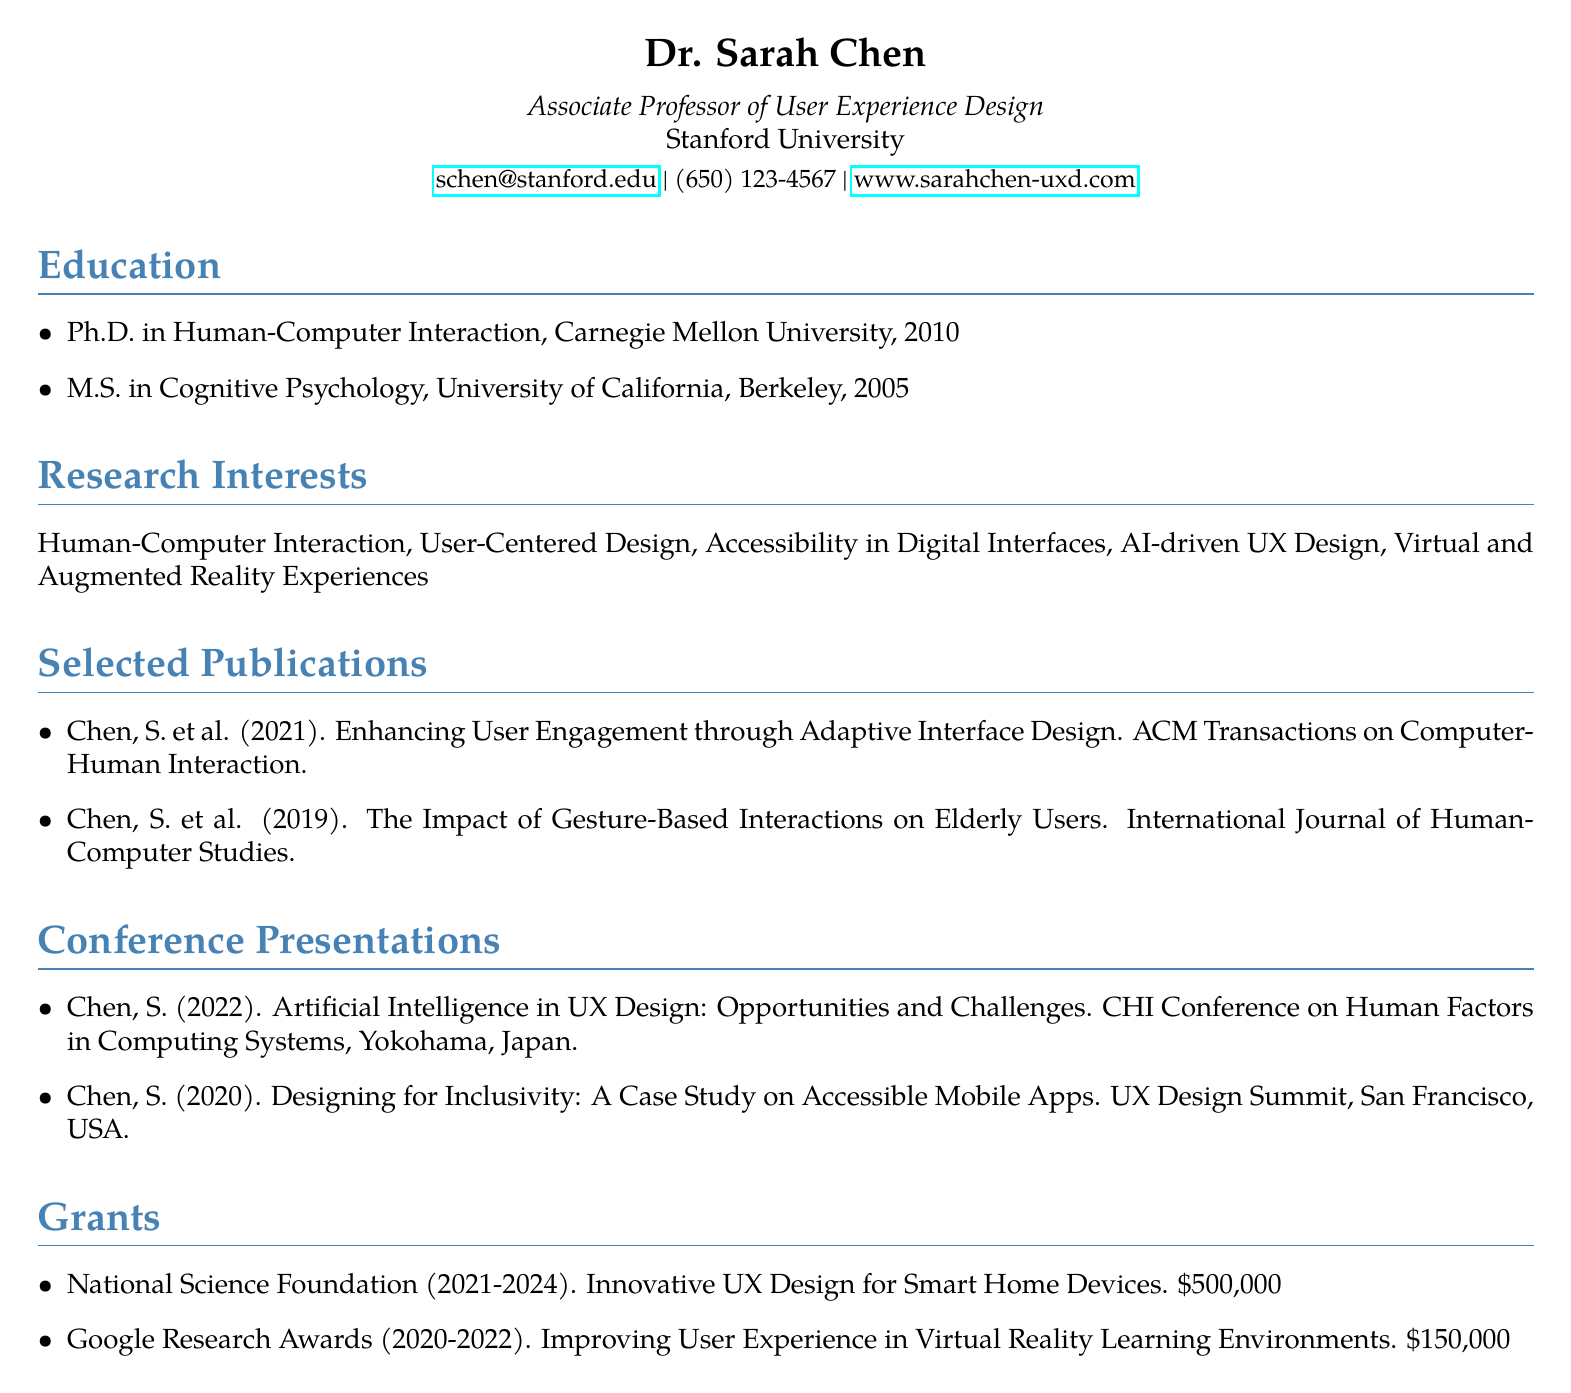What is the name of the professor? The name of the professor is listed at the top of the document under personal info.
Answer: Dr. Sarah Chen What year did Dr. Sarah Chen obtain her Ph.D.? The year of obtaining the degree is specified in the education section of the document.
Answer: 2010 What is the title of one of her publications published in 2021? The titles of the publications are located in the selected publications section.
Answer: Enhancing User Engagement through Adaptive Interface Design Which conference did she present at in 2022? The conference title is provided in the conference presentations section for the year 2022.
Answer: CHI Conference on Human Factors in Computing Systems How much funding did the National Science Foundation grant? The amount of funding is detailed in the grants section of the document.
Answer: $500,000 What are two of Dr. Sarah Chen's research interests? The research interests are listed in a separate section and can be chosen from that list.
Answer: Human-Computer Interaction, User-Centered Design What is the highest degree Dr. Sarah Chen has earned? This information can be found in the education section of the document.
Answer: Ph.D In which city was the UX Design Summit held? The location details of the conference presentations section specify the city of this event.
Answer: San Francisco What is the total duration of the grant from Google Research Awards? The duration can be calculated from the year range provided in the grants section.
Answer: 2 years 